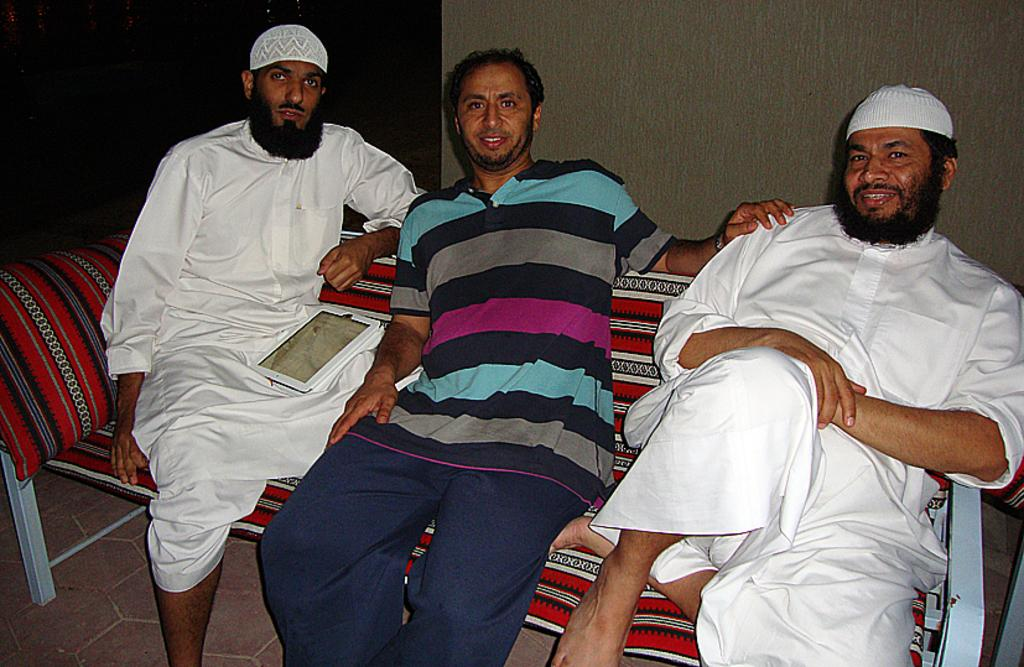How many people are in the image? There are three men in the image. What are the men doing in the image? The men are sitting on a sofa. What is behind the men in the image? There is a wall behind the men. What route do the men take to get to the sofa in the image? The image does not show the men moving or taking a route to the sofa; they are already sitting on it. 